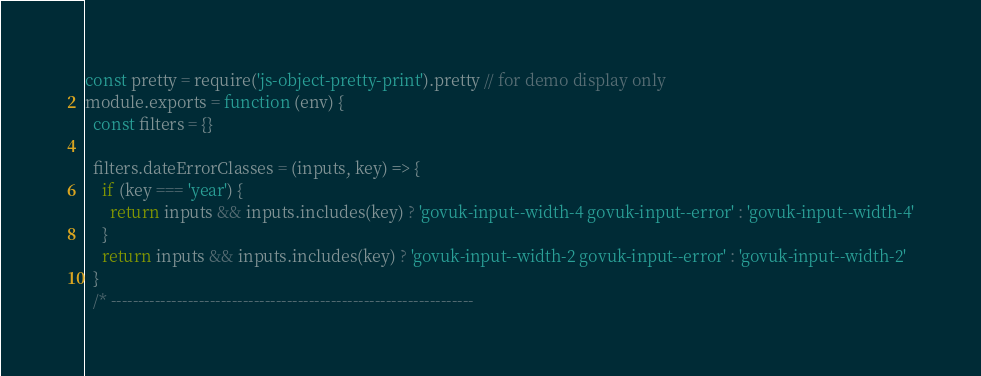<code> <loc_0><loc_0><loc_500><loc_500><_JavaScript_>const pretty = require('js-object-pretty-print').pretty // for demo display only
module.exports = function (env) {
  const filters = {}

  filters.dateErrorClasses = (inputs, key) => {
    if (key === 'year') {
      return inputs && inputs.includes(key) ? 'govuk-input--width-4 govuk-input--error' : 'govuk-input--width-4'
    }
    return inputs && inputs.includes(key) ? 'govuk-input--width-2 govuk-input--error' : 'govuk-input--width-2'
  }
  /* ------------------------------------------------------------------</code> 